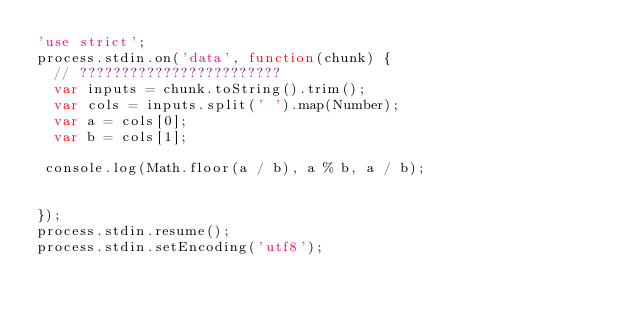<code> <loc_0><loc_0><loc_500><loc_500><_JavaScript_>'use strict';
process.stdin.on('data', function(chunk) {
  // ????????????????????????
  var inputs = chunk.toString().trim();
  var cols = inputs.split(' ').map(Number);
  var a = cols[0];
  var b = cols[1];

 console.log(Math.floor(a / b), a % b, a / b);


});
process.stdin.resume();
process.stdin.setEncoding('utf8');</code> 